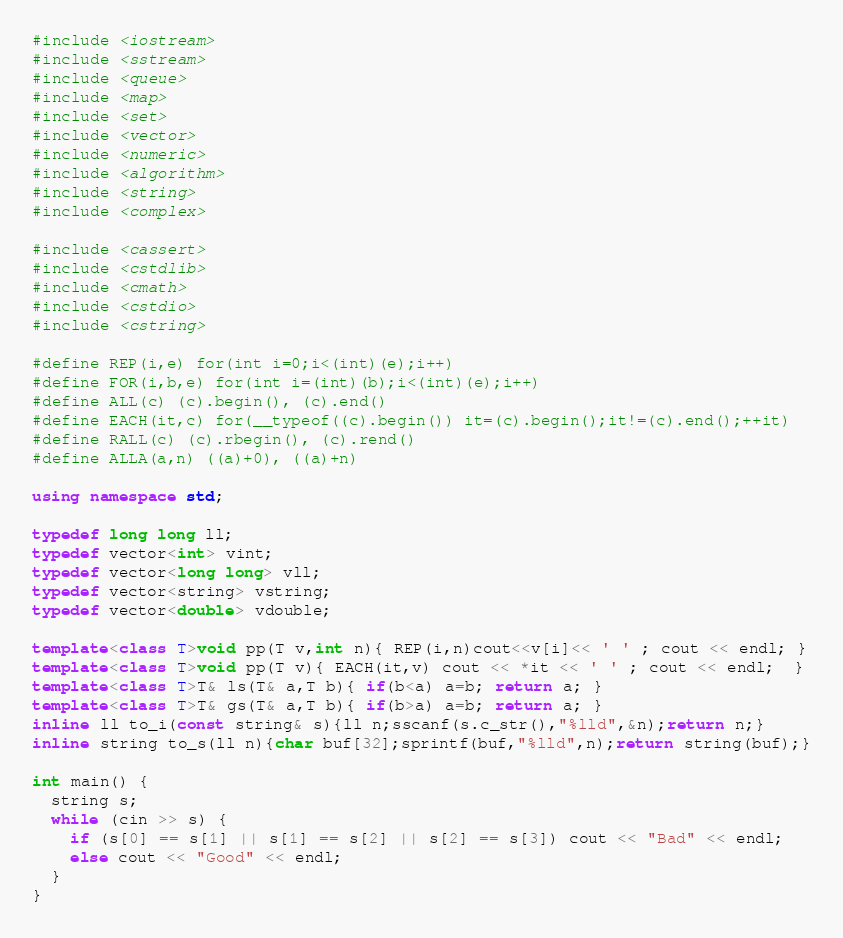<code> <loc_0><loc_0><loc_500><loc_500><_C++_>#include <iostream>
#include <sstream>
#include <queue>
#include <map>
#include <set>
#include <vector>
#include <numeric>
#include <algorithm>
#include <string>
#include <complex>
 
#include <cassert>
#include <cstdlib>
#include <cmath>
#include <cstdio>
#include <cstring>
 
#define REP(i,e) for(int i=0;i<(int)(e);i++)
#define FOR(i,b,e) for(int i=(int)(b);i<(int)(e);i++)
#define ALL(c) (c).begin(), (c).end()
#define EACH(it,c) for(__typeof((c).begin()) it=(c).begin();it!=(c).end();++it)
#define RALL(c) (c).rbegin(), (c).rend()
#define ALLA(a,n) ((a)+0), ((a)+n)
 
using namespace std;
 
typedef long long ll;
typedef vector<int> vint;
typedef vector<long long> vll;
typedef vector<string> vstring;
typedef vector<double> vdouble;
 
template<class T>void pp(T v,int n){ REP(i,n)cout<<v[i]<< ' ' ; cout << endl; }
template<class T>void pp(T v){ EACH(it,v) cout << *it << ' ' ; cout << endl;  }
template<class T>T& ls(T& a,T b){ if(b<a) a=b; return a; }
template<class T>T& gs(T& a,T b){ if(b>a) a=b; return a; }
inline ll to_i(const string& s){ll n;sscanf(s.c_str(),"%lld",&n);return n;}
inline string to_s(ll n){char buf[32];sprintf(buf,"%lld",n);return string(buf);}

int main() {
  string s;
  while (cin >> s) {
    if (s[0] == s[1] || s[1] == s[2] || s[2] == s[3]) cout << "Bad" << endl;
    else cout << "Good" << endl;
  }
}
</code> 